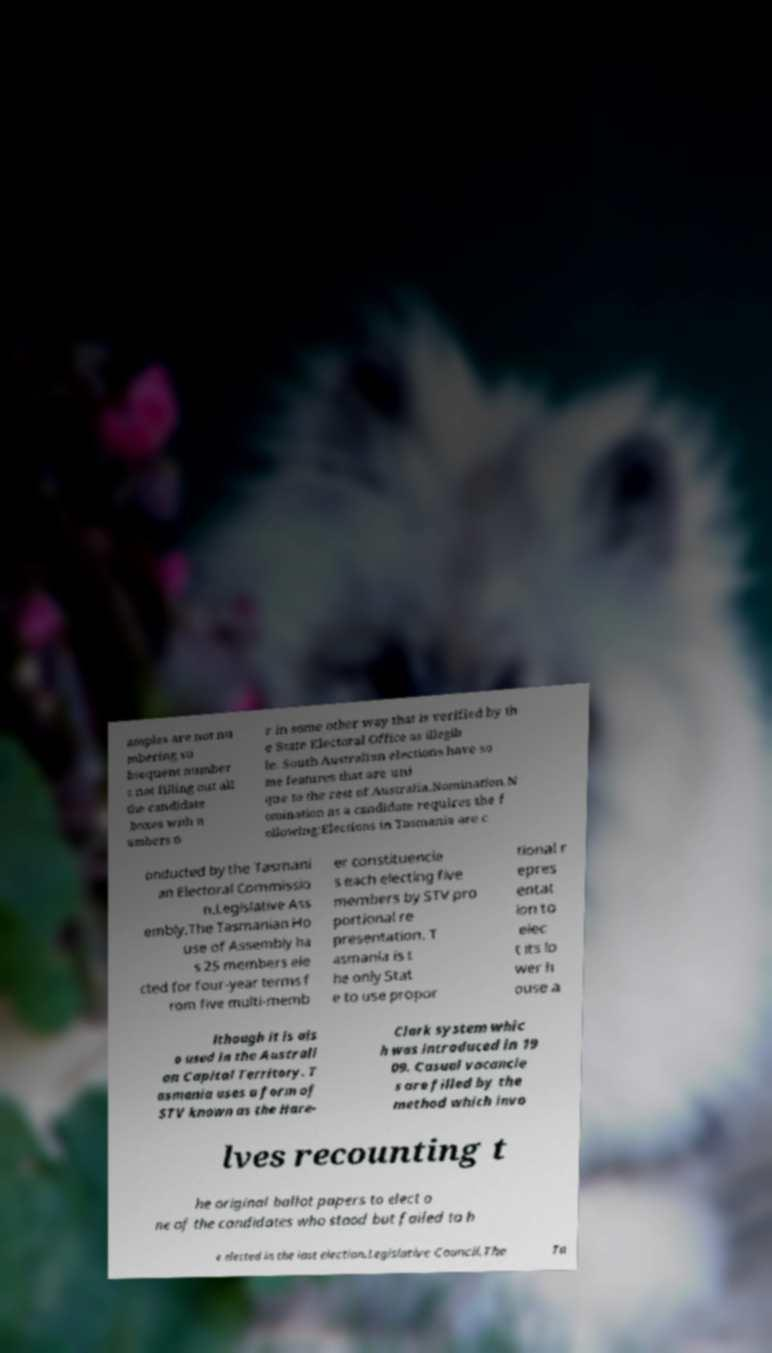Can you read and provide the text displayed in the image?This photo seems to have some interesting text. Can you extract and type it out for me? amples are not nu mbering su bsequent number s not filling out all the candidate boxes with n umbers o r in some other way that is verified by th e State Electoral Office as illegib le. South Australian elections have so me features that are uni que to the rest of Australia.Nomination.N omination as a candidate requires the f ollowing:Elections in Tasmania are c onducted by the Tasmani an Electoral Commissio n.Legislative Ass embly.The Tasmanian Ho use of Assembly ha s 25 members ele cted for four-year terms f rom five multi-memb er constituencie s each electing five members by STV pro portional re presentation. T asmania is t he only Stat e to use propor tional r epres entat ion to elec t its lo wer h ouse a lthough it is als o used in the Australi an Capital Territory. T asmania uses a form of STV known as the Hare- Clark system whic h was introduced in 19 09. Casual vacancie s are filled by the method which invo lves recounting t he original ballot papers to elect o ne of the candidates who stood but failed to b e elected in the last election.Legislative Council.The Ta 